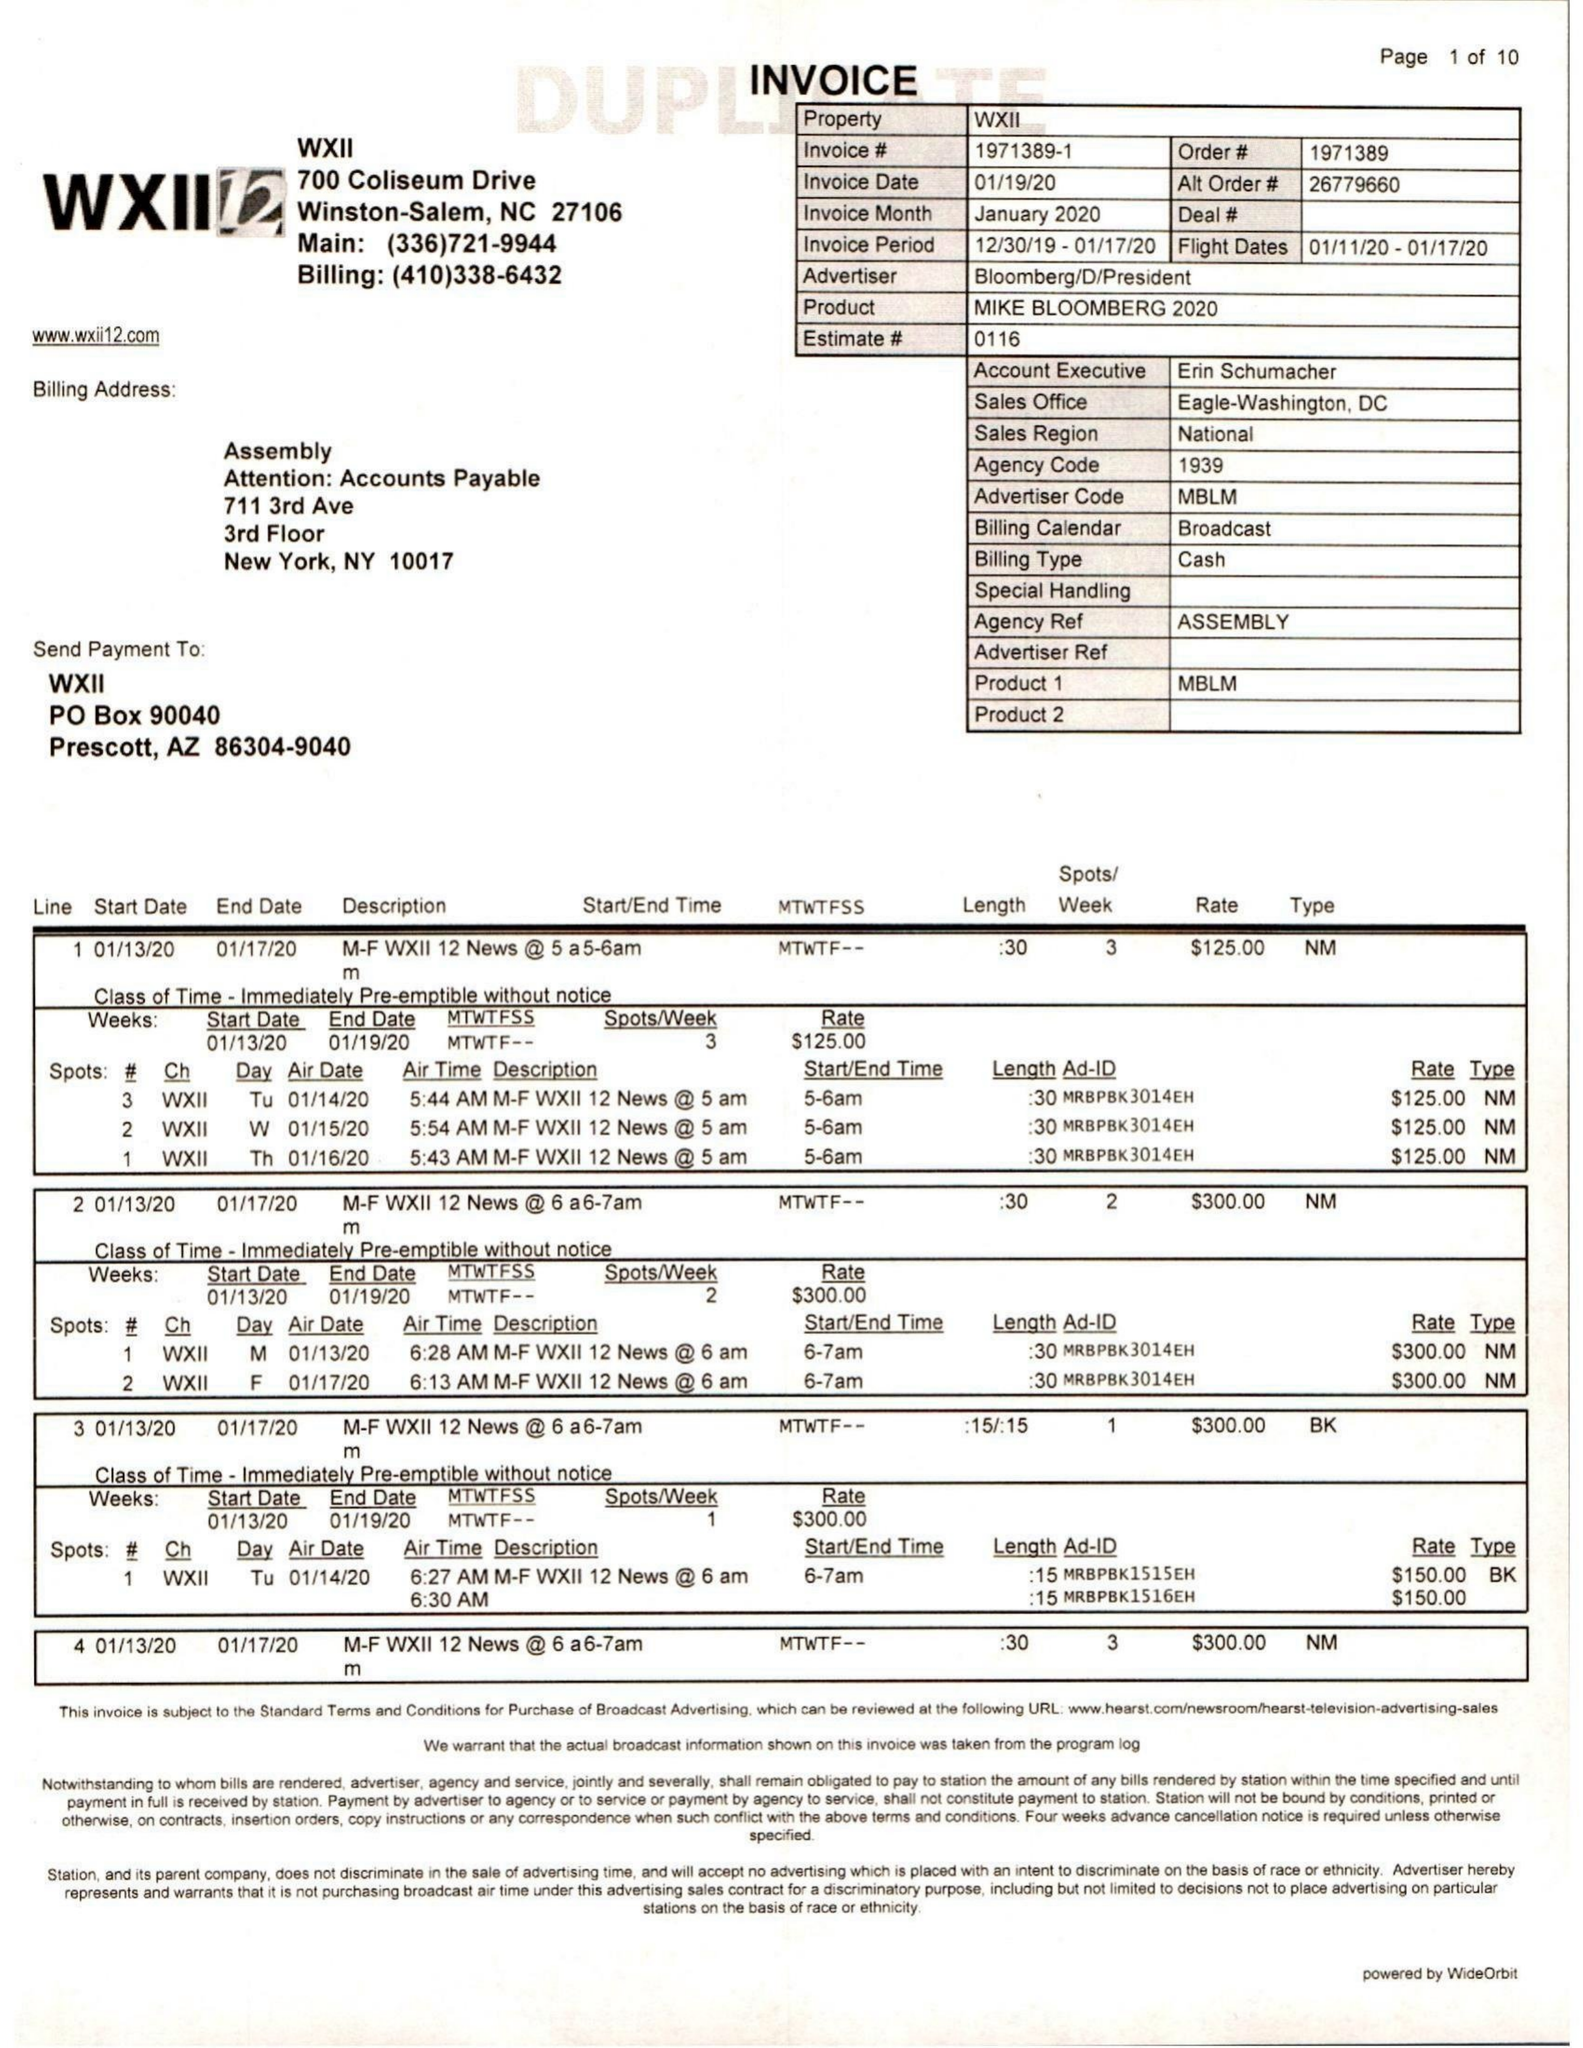What is the value for the advertiser?
Answer the question using a single word or phrase. BLOOMBERG/D/PRESIDENT 